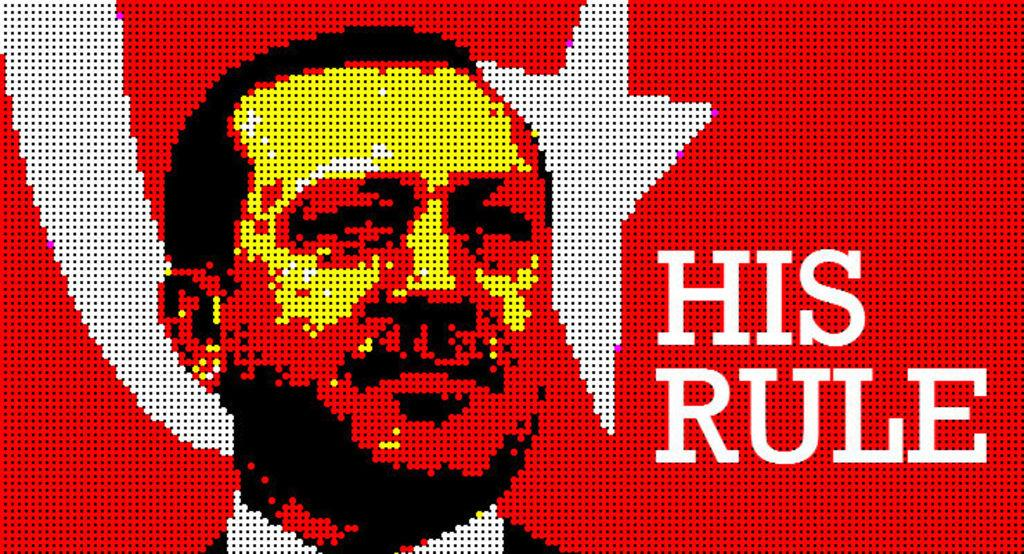Provide a one-sentence caption for the provided image. A pixelated poster of a man that says His Rule. 